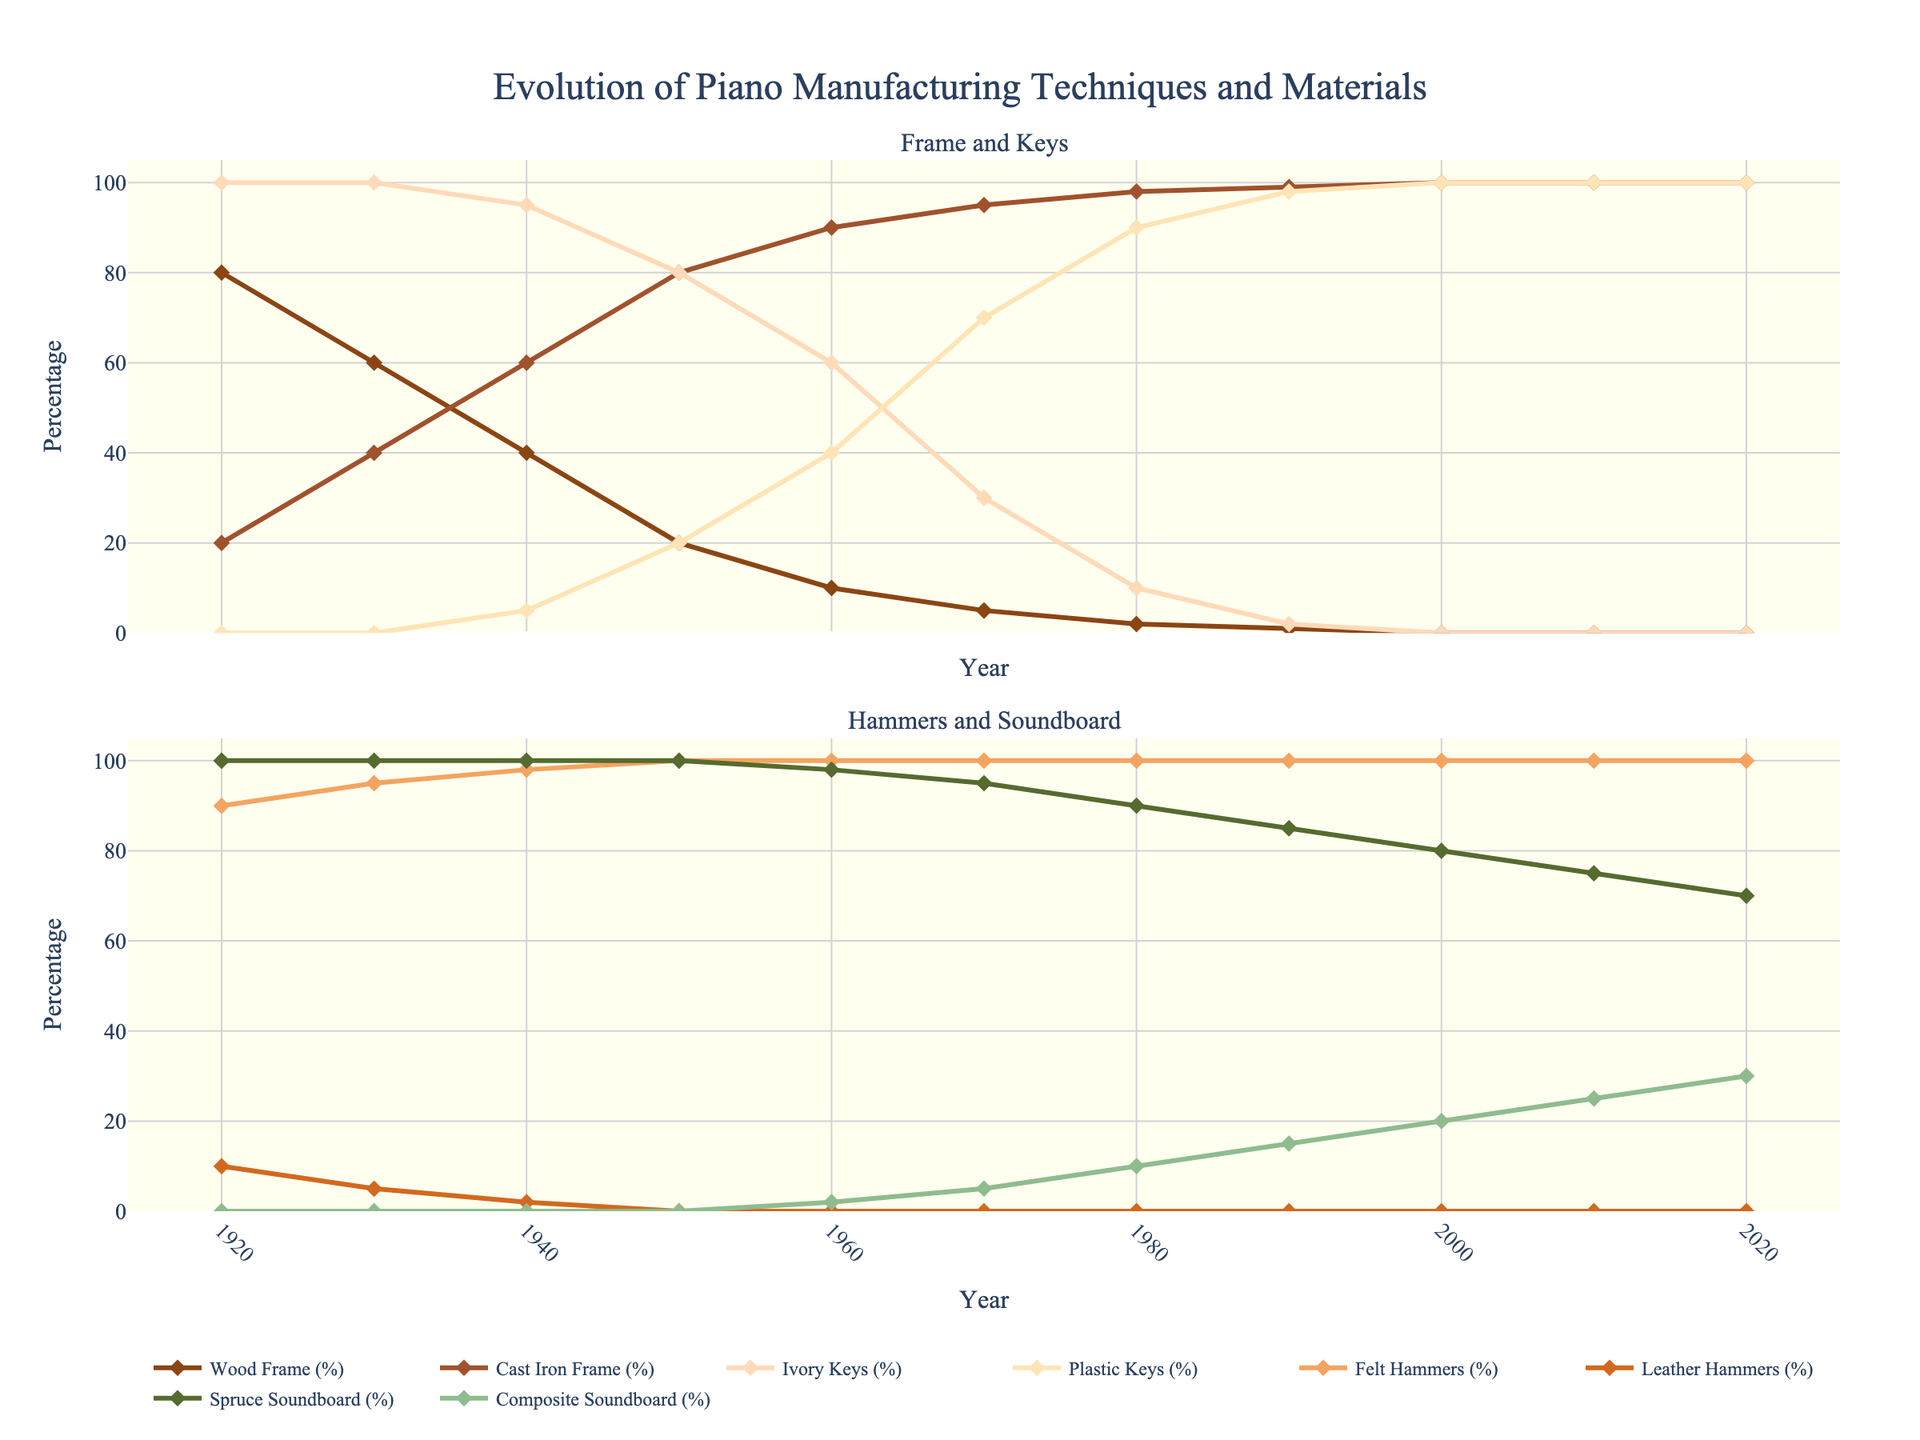What materials have completely disappeared from piano manufacturing by 2020? From the figure, by 2020, Wood Frame, Ivory Keys, and Leather Hammers have all reached 0%, indicating they are no longer used in piano manufacturing.
Answer: Wood Frame, Ivory Keys, Leather Hammers Which frame type shows a clear shift and when did it occur? The Wood Frame usage steadily declines, reaching 0% by 2000, while the Cast Iron Frame increases to 100% by the same time. There is a clear shift where Wood Frame is replaced by Cast Iron Frame from 1920 to 2000.
Answer: Wood Frame to Cast Iron Frame, by 2000 In which decade did the use of plastic keys surpass that of ivory keys? From the figure, plastic keys exceed ivory keys in the year 1950, indicating the transition occurs in the 1950s.
Answer: 1950s What can you infer about the usage trend of Felt Hammers and Leather Hammers over the century? Felt Hammers remain at a high and consistent usage of around 90-100% throughout the century, whereas Leather Hammers decline to 0% by 1950.
Answer: Felt Hammers are consistently high, Leather Hammers decline to 0% Compare and contrast the trends in the usage of Spruce Soundboard and Composite Soundboard. Initially, Spruce Soundboard is at 100%, and Composite Soundboard is at 0%. Over the century, Spruce declines to 70%, while Composite increases to 30%, indicating a gradual shift towards composite materials.
Answer: Spruce declines, Composite increases When did Felt Hammers reach 100% usage, and has it retained that since? Felt Hammers reached 100% by 1950 and have maintained that level since then, as per the figure.
Answer: 1950, Yes What is the trend for Cast Iron Frame between 1920 to 1960? The Cast Iron Frame steadily increases from 20% in 1920 to 90% in 1960, indicating a shift towards its usage over these years.
Answer: Increasing from 20% to 90% Calculate the difference in Ivory Keys usage between 1920 and 1980. In 1920, Ivory Keys are at 100%. By 1980, they decline to 10%. The difference is 100% - 10% = 90%.
Answer: 90% Which year did Composite Soundboard first appear and what was its initial percentage? Composite Soundboard first appears in the chart in the year 1960 with an initial percentage of 2%.
Answer: 1960, 2% Can you identify a year where major changes happened for multiple components? The year 1950 marks significant changes: Wood Frame drops to 20%, Cast Iron Frame rises to 80%, Ivory Keys drop to 80%, Plastic Keys appear at 20%, and Leather Hammers drop to 0%.
Answer: 1950 